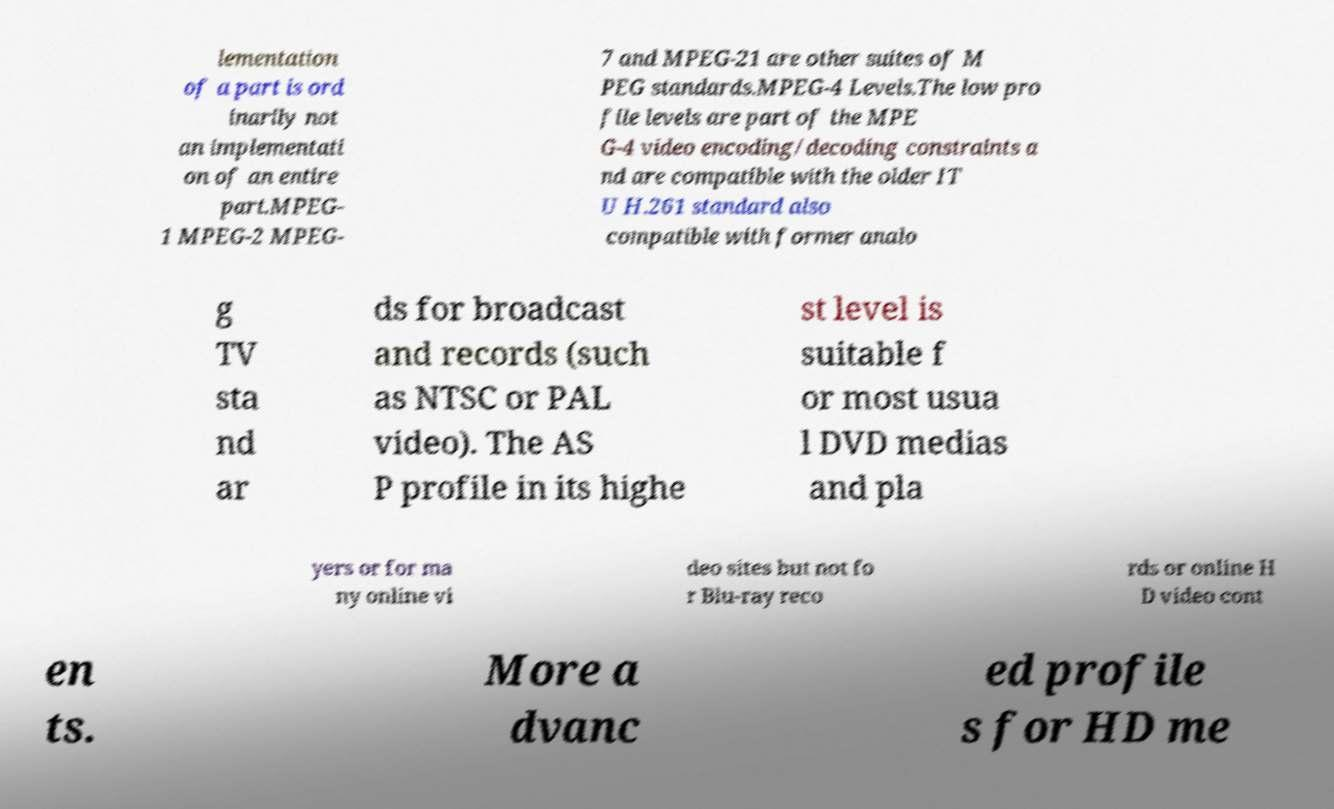Could you extract and type out the text from this image? lementation of a part is ord inarily not an implementati on of an entire part.MPEG- 1 MPEG-2 MPEG- 7 and MPEG-21 are other suites of M PEG standards.MPEG-4 Levels.The low pro file levels are part of the MPE G-4 video encoding/decoding constraints a nd are compatible with the older IT U H.261 standard also compatible with former analo g TV sta nd ar ds for broadcast and records (such as NTSC or PAL video). The AS P profile in its highe st level is suitable f or most usua l DVD medias and pla yers or for ma ny online vi deo sites but not fo r Blu-ray reco rds or online H D video cont en ts. More a dvanc ed profile s for HD me 